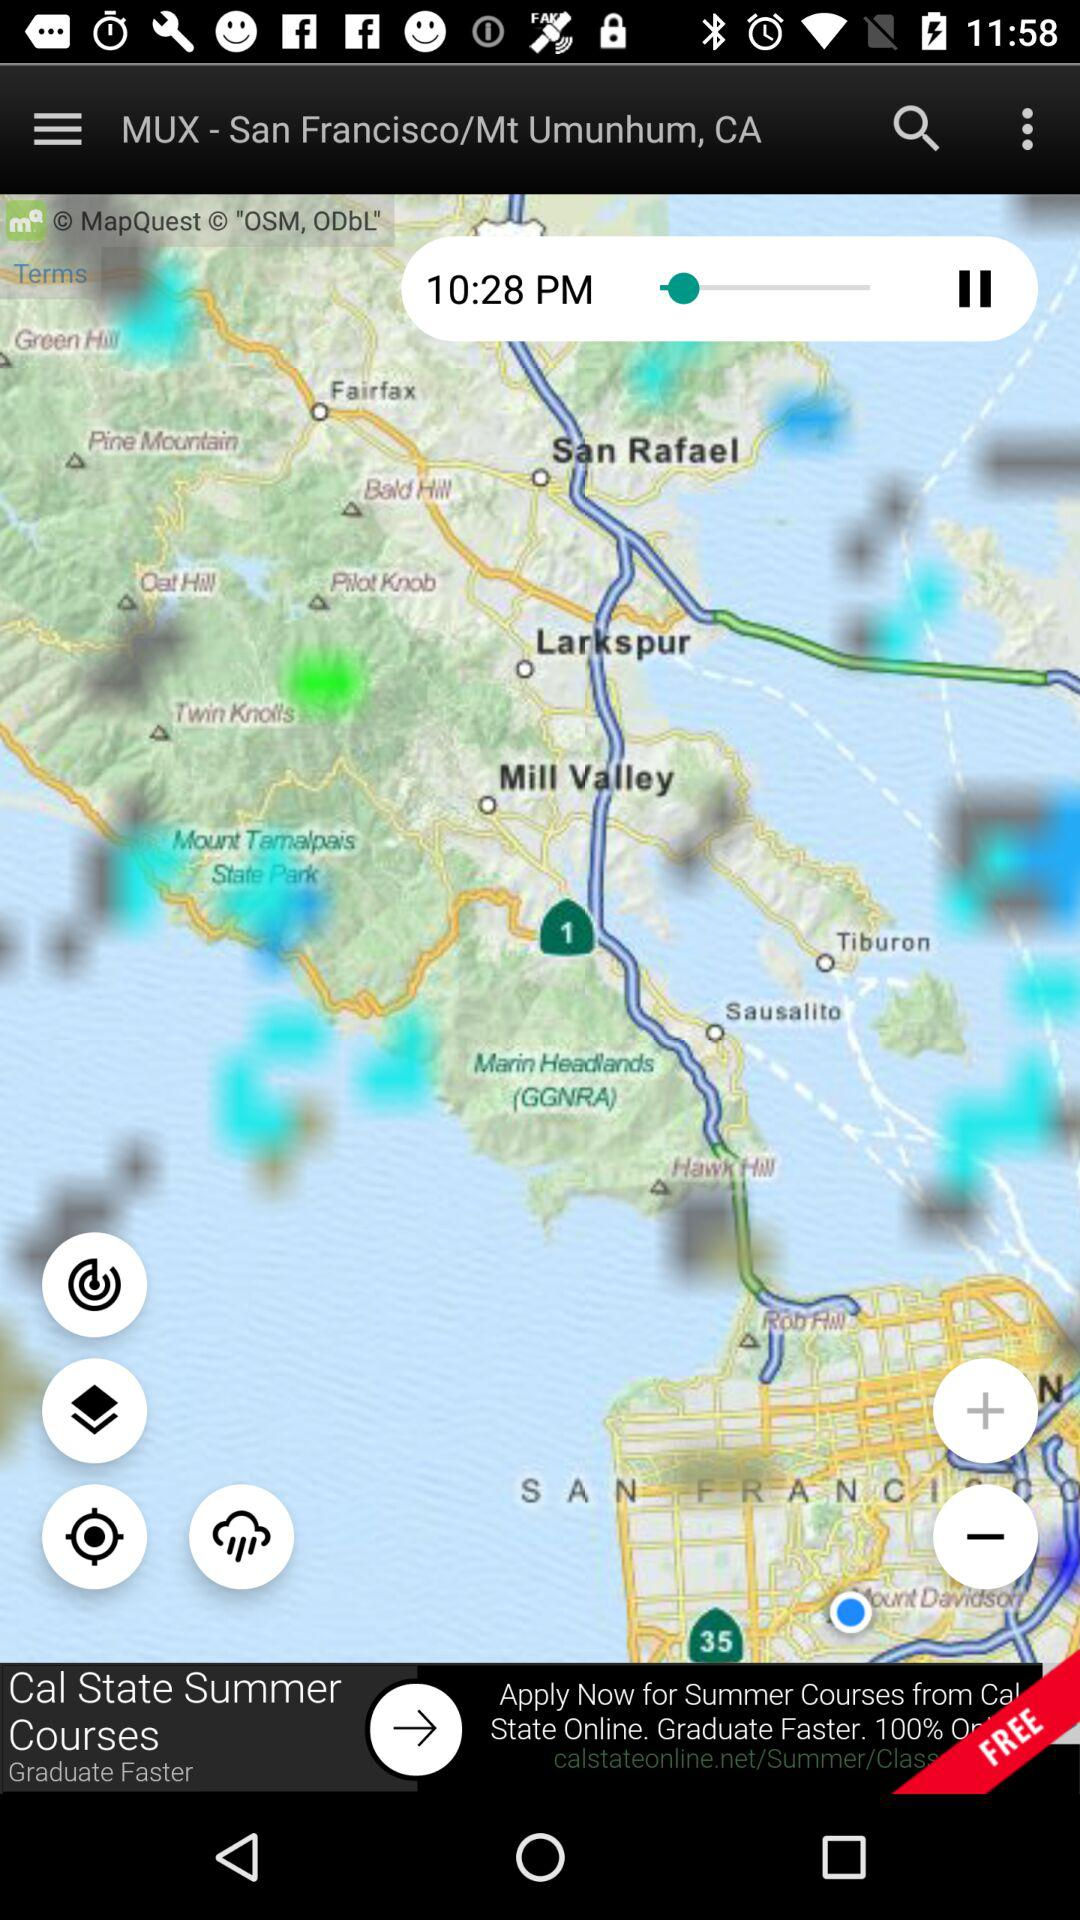What is the location? The location is "MUX - San Francisco/Mt Umunhum, CA". 